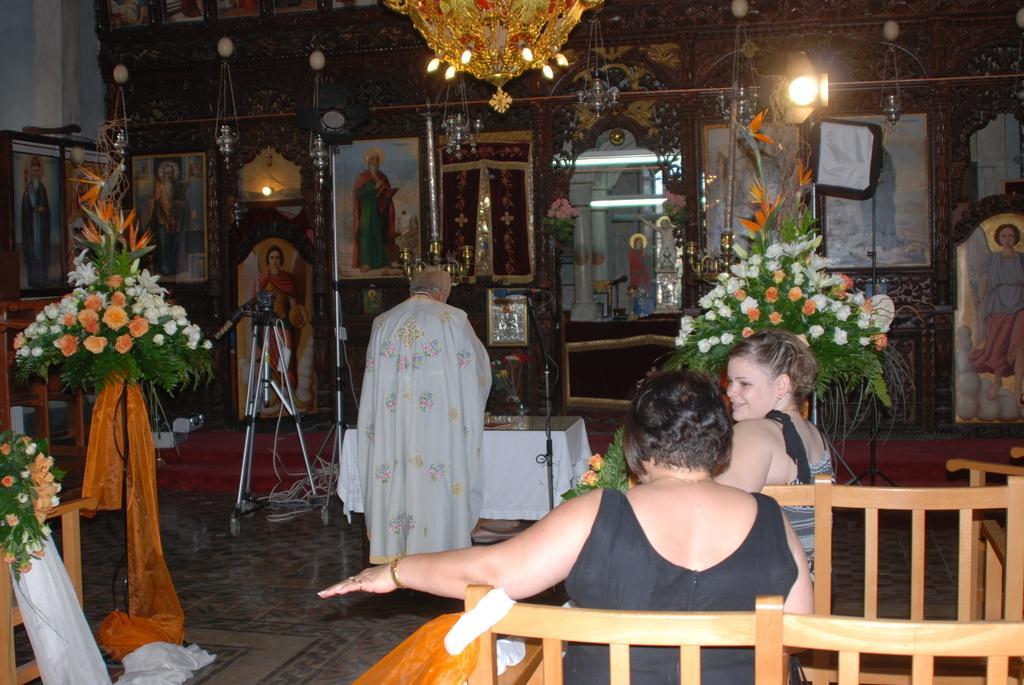How would you summarize this image in a sentence or two? People are sitting on the bench,man standing,here there are photo frames on the wall,this is plant. 